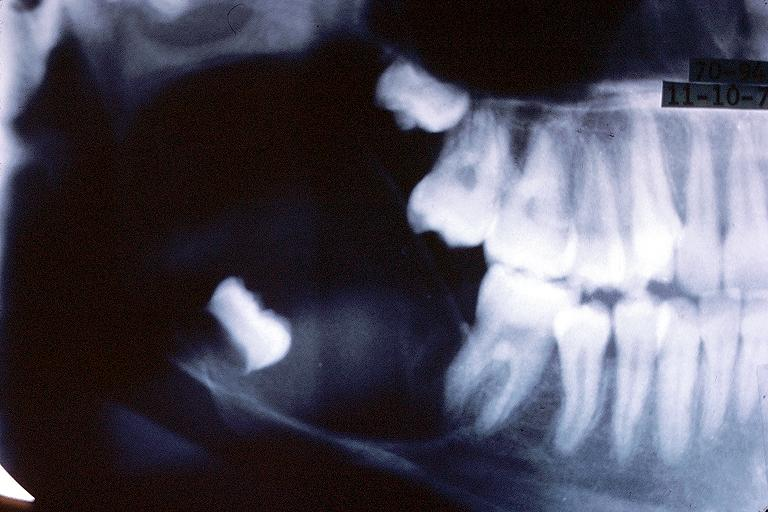where is this?
Answer the question using a single word or phrase. Oral 